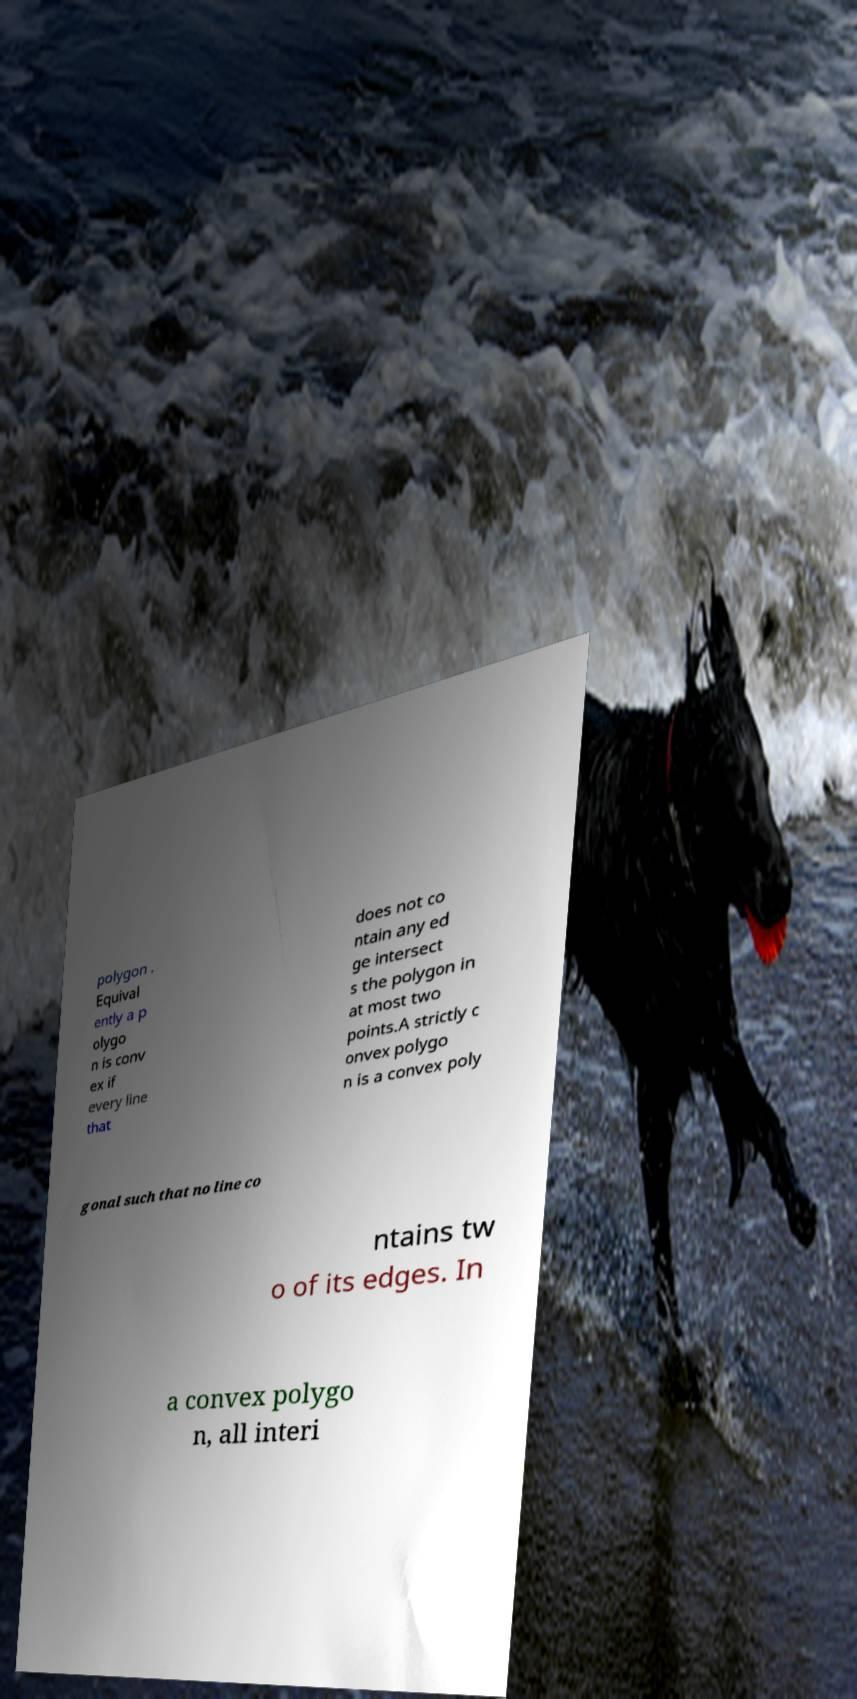Please identify and transcribe the text found in this image. polygon . Equival ently a p olygo n is conv ex if every line that does not co ntain any ed ge intersect s the polygon in at most two points.A strictly c onvex polygo n is a convex poly gonal such that no line co ntains tw o of its edges. In a convex polygo n, all interi 